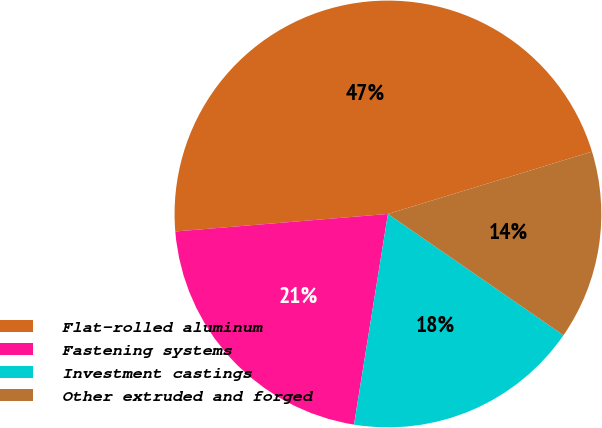Convert chart to OTSL. <chart><loc_0><loc_0><loc_500><loc_500><pie_chart><fcel>Flat-rolled aluminum<fcel>Fastening systems<fcel>Investment castings<fcel>Other extruded and forged<nl><fcel>46.59%<fcel>21.15%<fcel>17.92%<fcel>14.34%<nl></chart> 